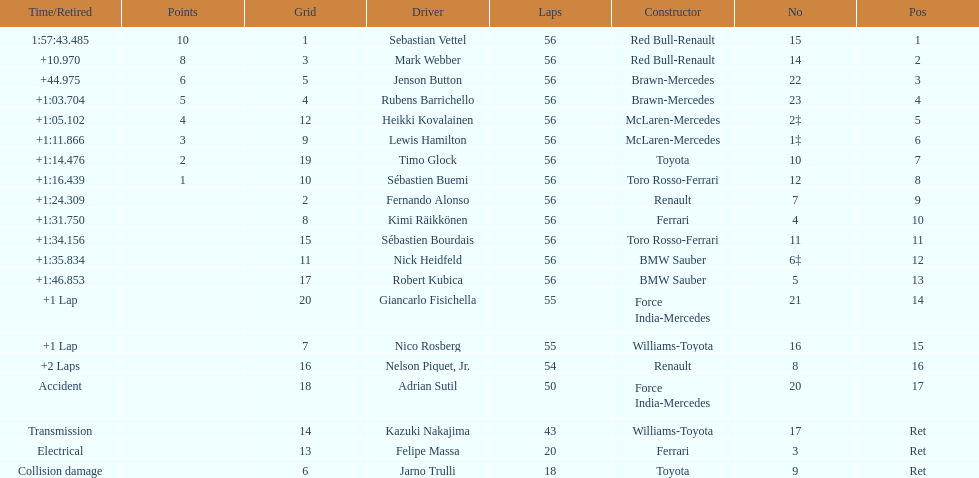How many laps in total is the race? 56. 